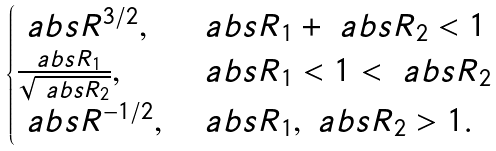Convert formula to latex. <formula><loc_0><loc_0><loc_500><loc_500>\begin{cases} \ a b s { R } ^ { 3 / 2 } , & \ a b s { R _ { 1 } } + \ a b s { R _ { 2 } } < 1 \\ \frac { \ a b s { R _ { 1 } } } { \sqrt { \ a b s { R _ { 2 } } } } , & \ a b s { R _ { 1 } } < 1 < \ a b s { R _ { 2 } } \\ \ a b s { R } ^ { - 1 / 2 } , & \ a b s { R _ { 1 } } , \ a b s { R _ { 2 } } > 1 . \end{cases}</formula> 